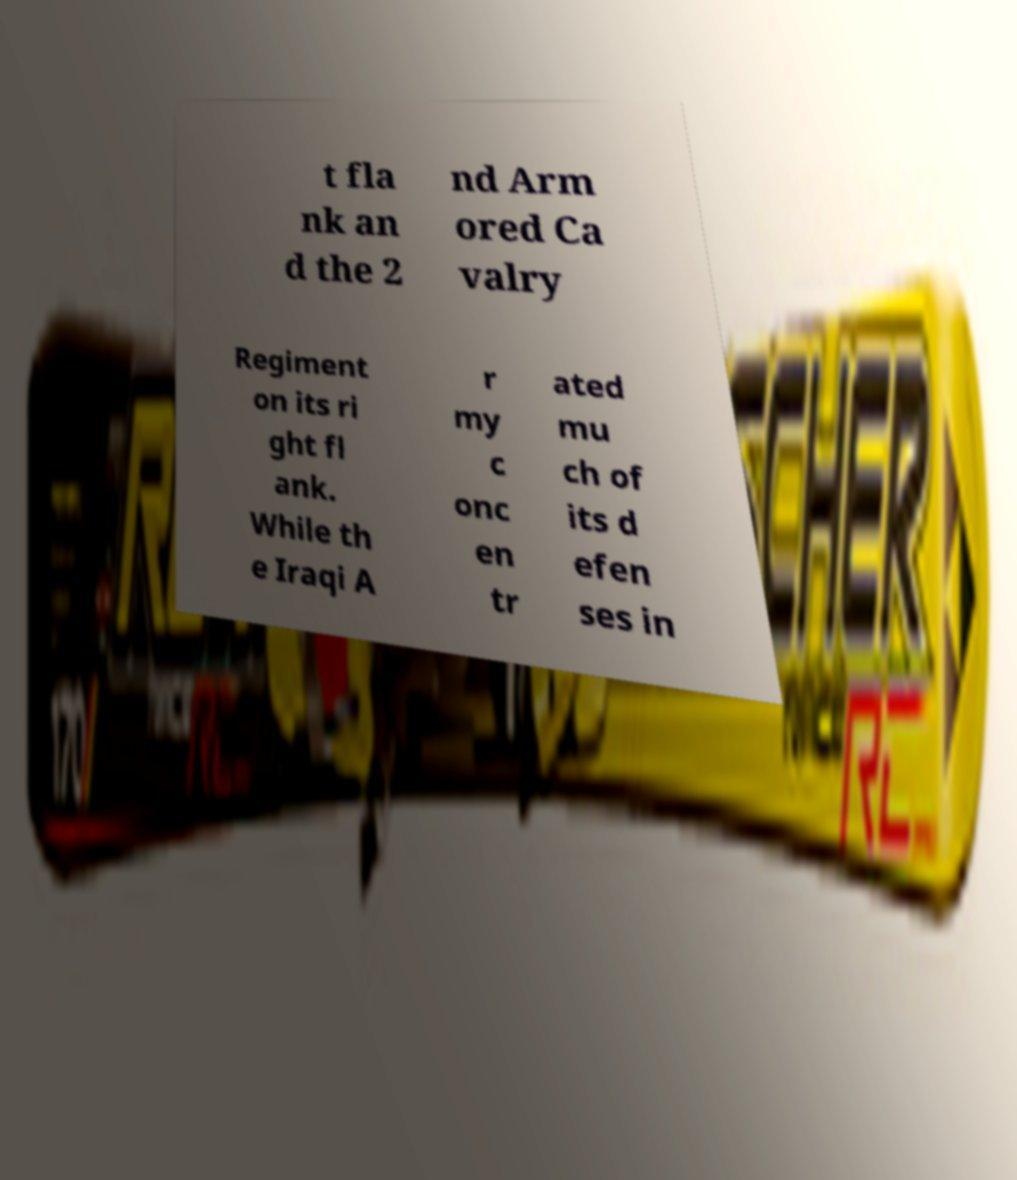What messages or text are displayed in this image? I need them in a readable, typed format. t fla nk an d the 2 nd Arm ored Ca valry Regiment on its ri ght fl ank. While th e Iraqi A r my c onc en tr ated mu ch of its d efen ses in 